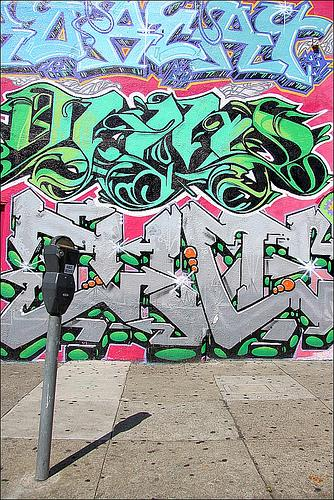List down the different aspects of graffiti present in the image. The graffiti includes colorful work, light blue letters, green circles, blue writing, and has been done on the wall as street art. Analyze the interaction between the parking meter and its surroundings in the image. The parking meter is attached to a metal pole and placed on the concrete sidewalk. Its black color stands out against the grey surroundings, while a white and black sticker is nearby. What is the primary artwork displayed in the image? A large piece of street art with colorful graffiti work on the wall, containing some light blue letters, green circles, and blue writing. What is the sentiment conveyed by the image, based on the street art present in the scene? The sentiment conveyed is creativity and vibrancy as the colorful graffiti work, including light blue letters and green circles, showcases artistic expression. Based on the visible elements, what time of day could this image have been taken? It appears to be a daytime picture, as evidenced by the presence of shadows and daylight in the scene. Describe the appearance and location of the parking meter in the image. The metal parking meter is black in color, located on the grey concrete sidewalk, and attached to a scratched grey pole. Can you identify any visual elements related to the shades and shadows in the image? There are part of a shade and edge of a shade, along with a shadow on the sidewalk and a shadow that falls on the sidewalk. In the image, which objects suggest that the location could be an urban setting? The graffiti, metal parking meter, concrete sidewalk, and presence of a pole and floor squares indicate an urban setting. Mention a few observable features of the sidewalk in the image. The sidewalk is grey in color, made of concrete, and has some old gum on the floor. There is also a shadow on the sidewalk. Find the color of a graffiti painting. Cannot identify the color of a specific graffiti painting as multiple graffiti works are present with various colors. Identify the reason for the presence of a shadow on the sidewalk. The shadow on the sidewalk is caused by the angle of the sun or another light source illuminating the scene. What color is the parking meter, and where is it located? The parking meter is black and located in the sidewalk. Explain the significance of the different graffiti colors in the wall. The diversity of colors represents the varied creative expressions and individuality of the artists contributing to the graffiti work. Is the sidewalk made of concrete in the image? Yes, the sidewalk is made of concrete. Are you able to see the bicycle parked near the graffiti wall? In the image, a bicycle is resting against the graffiti-covered wall, showcasing urban street life. Determine the color of the pole in the image. Grey Could you find the blue bird perched on top of the metal pole? A blue bird is casually sitting on the scratched metal pole, enjoying the day. Can you spot a person in a yellow jacket walking across the grey sidewalk? There's a person wearing a bright yellow jacket, adding a pop of color to the otherwise grey sidewalk. What does the presence of old gum on the floor signify? It signifies a lack of proper waste disposals or disregard for cleanliness by those who discard gum inappropriately. Analyze the relationship between the shadow and the sidewalk in the image. The shadow falls on the grey concrete sidewalk, creating a contrast between light and dark areas. What story do the multiple graffiti in the wall tell? The story of various artists expressing their creativity through unique styles, colors, and patterns of graffiti art. Include the color, material and attribute in a description of the parking meter in the image. A black metal parking meter attached to a grey scratched metal pole. Do you notice the tall tree casting a long shadow on the ground? In the image, there's a large tree with its shadow stretching across the sidewalk. How is the parking meter attached? The parking meter is attached to the pole. Deduce the activity that can be inferred from the old gum on the floor in the image. Chewing gum and later discarding it on the floor.  Describe the type of art shown in the image. A large piece of street art with colorful graffiti work and some writing in blue, with light blue letters and green circles. Describe the day time temperature in the image. Cannot infer the temperature from the image. Can you make out the running dog near the center of the image? In the picture you will find a dog running near the center, captured in perfect motion. Do you see that red fire hydrant on the edge of the sidewalk? There's a fire hydrant painted vividly red placed right next to the sidewalk. Provide a description of the graffiti on the wall, demonstrating various artistic styles present in the image. The graffiti consists of colorful street art, light blue letters, some writing in blue, and a few green circles, showing diverse artistic styles. What do the few mismatched squares represent in the image? The mismatched squares represent a diverse and creative choice of street art elements or objects. Which two colors can you see on the sticker in the image? White and black 